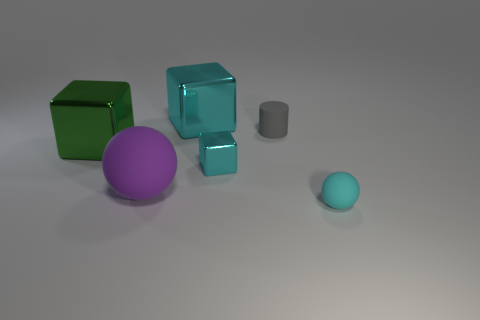How big is the cyan metallic thing in front of the large block that is on the left side of the large matte sphere?
Provide a succinct answer. Small. What color is the other big shiny thing that is the same shape as the green thing?
Your answer should be compact. Cyan. How big is the purple sphere?
Provide a succinct answer. Large. How many cubes are big cyan things or gray matte objects?
Make the answer very short. 1. There is a green metallic thing that is the same shape as the large cyan thing; what size is it?
Offer a terse response. Large. What number of big matte spheres are there?
Provide a succinct answer. 1. There is a small gray thing; does it have the same shape as the big cyan object that is left of the tiny cyan block?
Keep it short and to the point. No. What is the size of the cube behind the big green cube?
Your answer should be compact. Large. What is the small cylinder made of?
Ensure brevity in your answer.  Rubber. Is the shape of the tiny rubber thing left of the small cyan sphere the same as  the large matte thing?
Your answer should be very brief. No. 